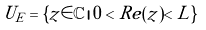Convert formula to latex. <formula><loc_0><loc_0><loc_500><loc_500>U _ { E } = \{ z \in \mathbb { C } \, | \, 0 < R e ( z ) < L \}</formula> 